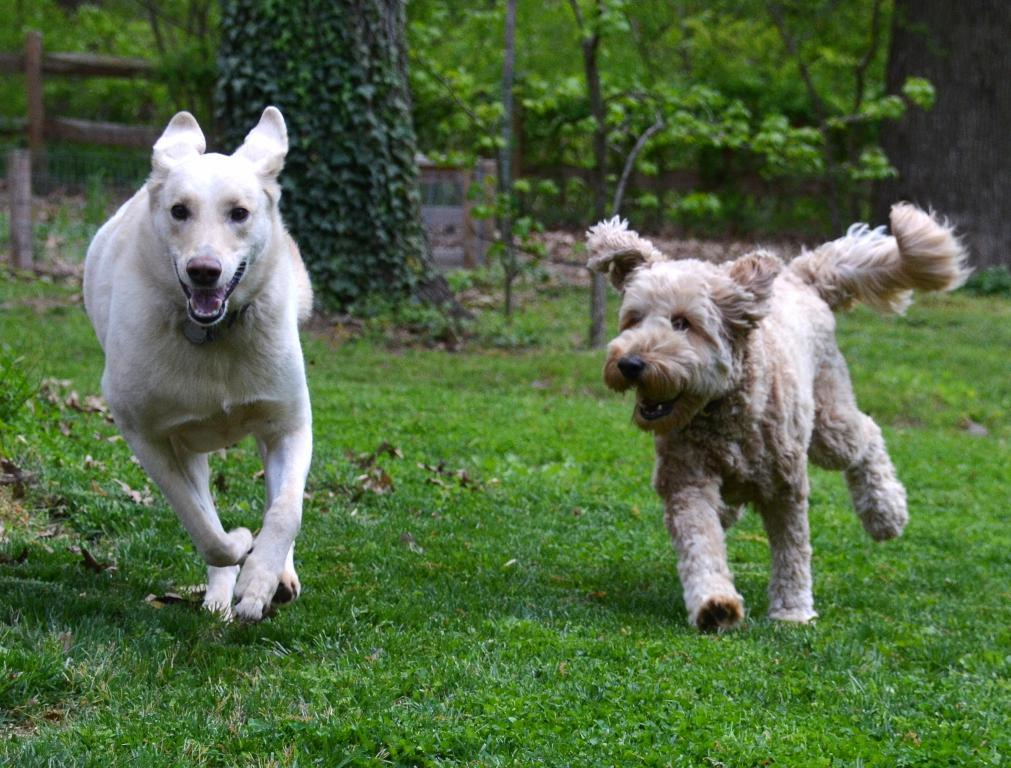How many dogs are present in the image? There are two dogs in the image. What are the dogs doing in the image? The dogs are running on the grass. What can be seen in the background of the image? There are plants, trees, and a wooden railing in the background of the image. What type of coal is being used to draw on the wooden railing in the image? There is no coal or drawing present in the image; it features two dogs running on the grass with a background of plants, trees, and a wooden railing. 